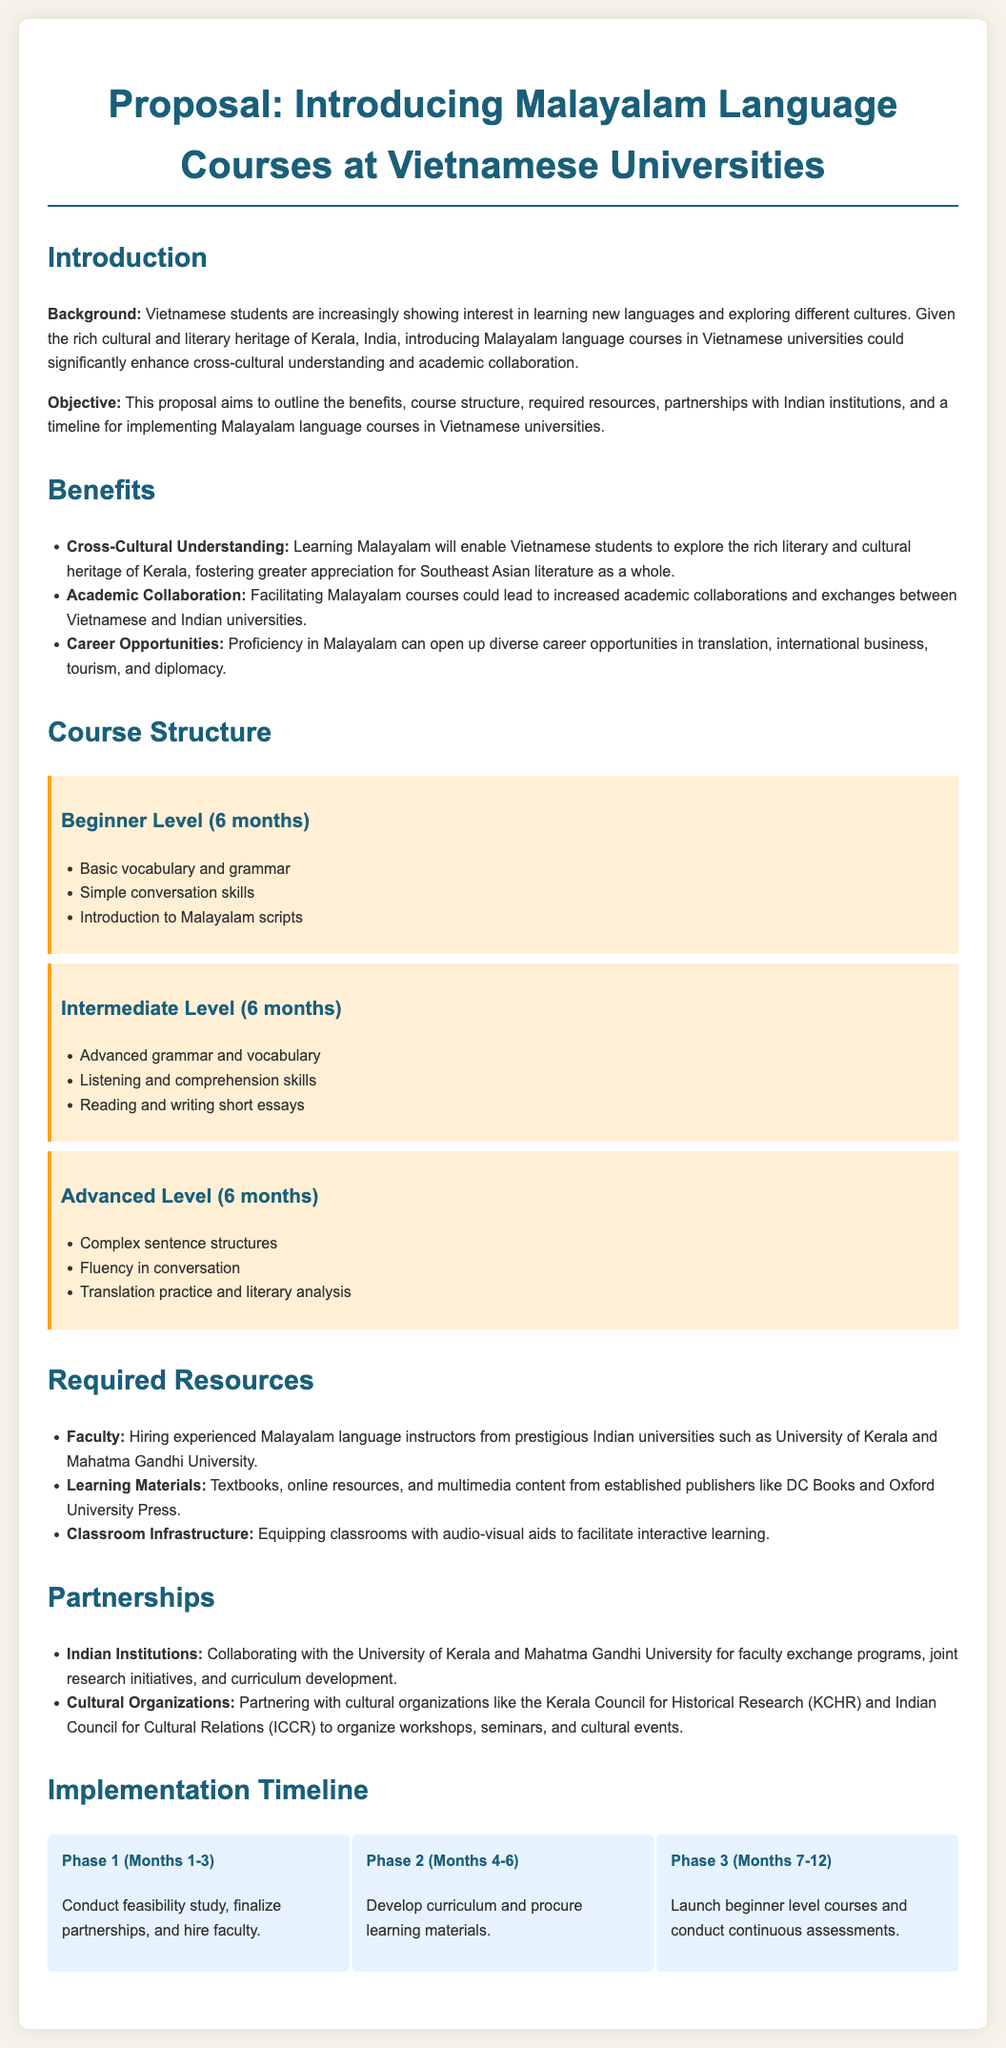What is the duration of the beginner level course? The document states that the beginner level course lasts for 6 months.
Answer: 6 months What are the names of the Indian institutions mentioned for partnerships? The proposal specifically mentions the University of Kerala and Mahatma Gandhi University for partnerships.
Answer: University of Kerala, Mahatma Gandhi University What types of career opportunities can proficiency in Malayalam lead to? The document lists various fields such as translation, international business, tourism, and diplomacy for career opportunities.
Answer: Translation, international business, tourism, diplomacy How many months are allocated for each course level? The document states that each course level (beginner, intermediate, advanced) is allocated 6 months, totaling 18 months for all three.
Answer: 6 months What phase involves launching beginner level courses? According to the implementation timeline, Phase 3 (Months 7-12) involves launching beginner level courses.
Answer: Phase 3 What is highlighted in the course structure section as learning focus for advanced level? The advanced level focuses on complex sentence structures, fluency in conversation, and translation practice and literary analysis.
Answer: Complex sentence structures, fluency in conversation, translation practice and literary analysis Which organizations are suggested for cultural partnership? The proposal suggests partnering with the Kerala Council for Historical Research and Indian Council for Cultural Relations.
Answer: Kerala Council for Historical Research, Indian Council for Cultural Relations What is the first step in the implementation timeline? The first step (Phase 1) includes conducting a feasibility study, finalizing partnerships, and hiring faculty.
Answer: Conduct feasibility study, finalize partnerships, hire faculty 